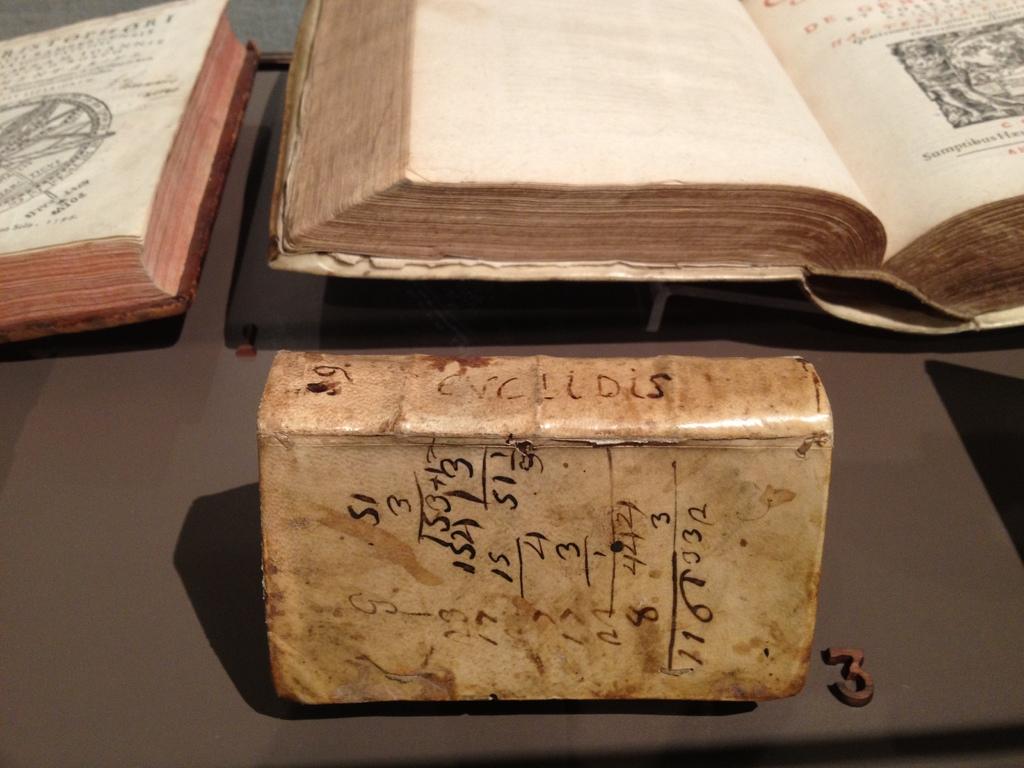What is wrote on the side of the book?
Your answer should be compact. Evclidis. 